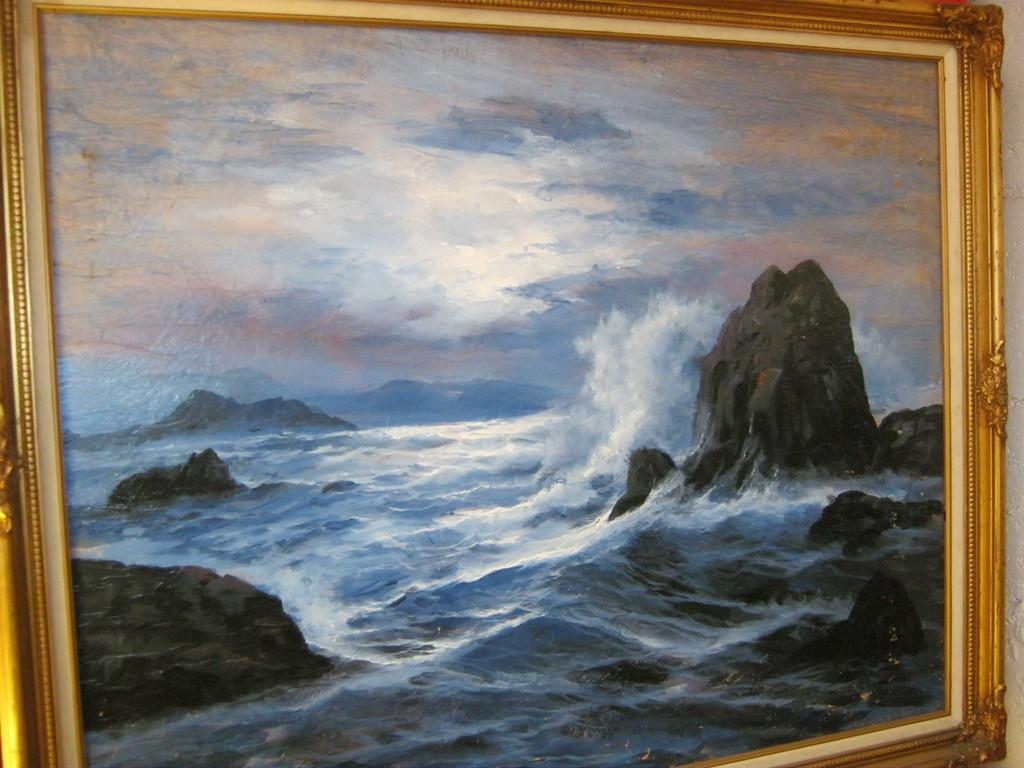What is the main subject of the image? The main subject of the image is a frame. What can be seen inside the frame? Water, rocks, and the sky are visible within the frame. What type of beast can be seen roaming around within the frame? There is no beast present within the frame; it contains water, rocks, and the sky. 